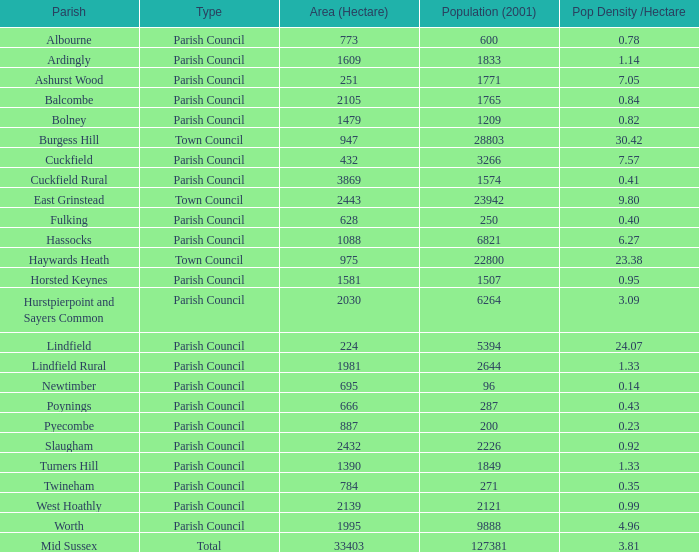What is the total area covered by worth parish? 1995.0. 